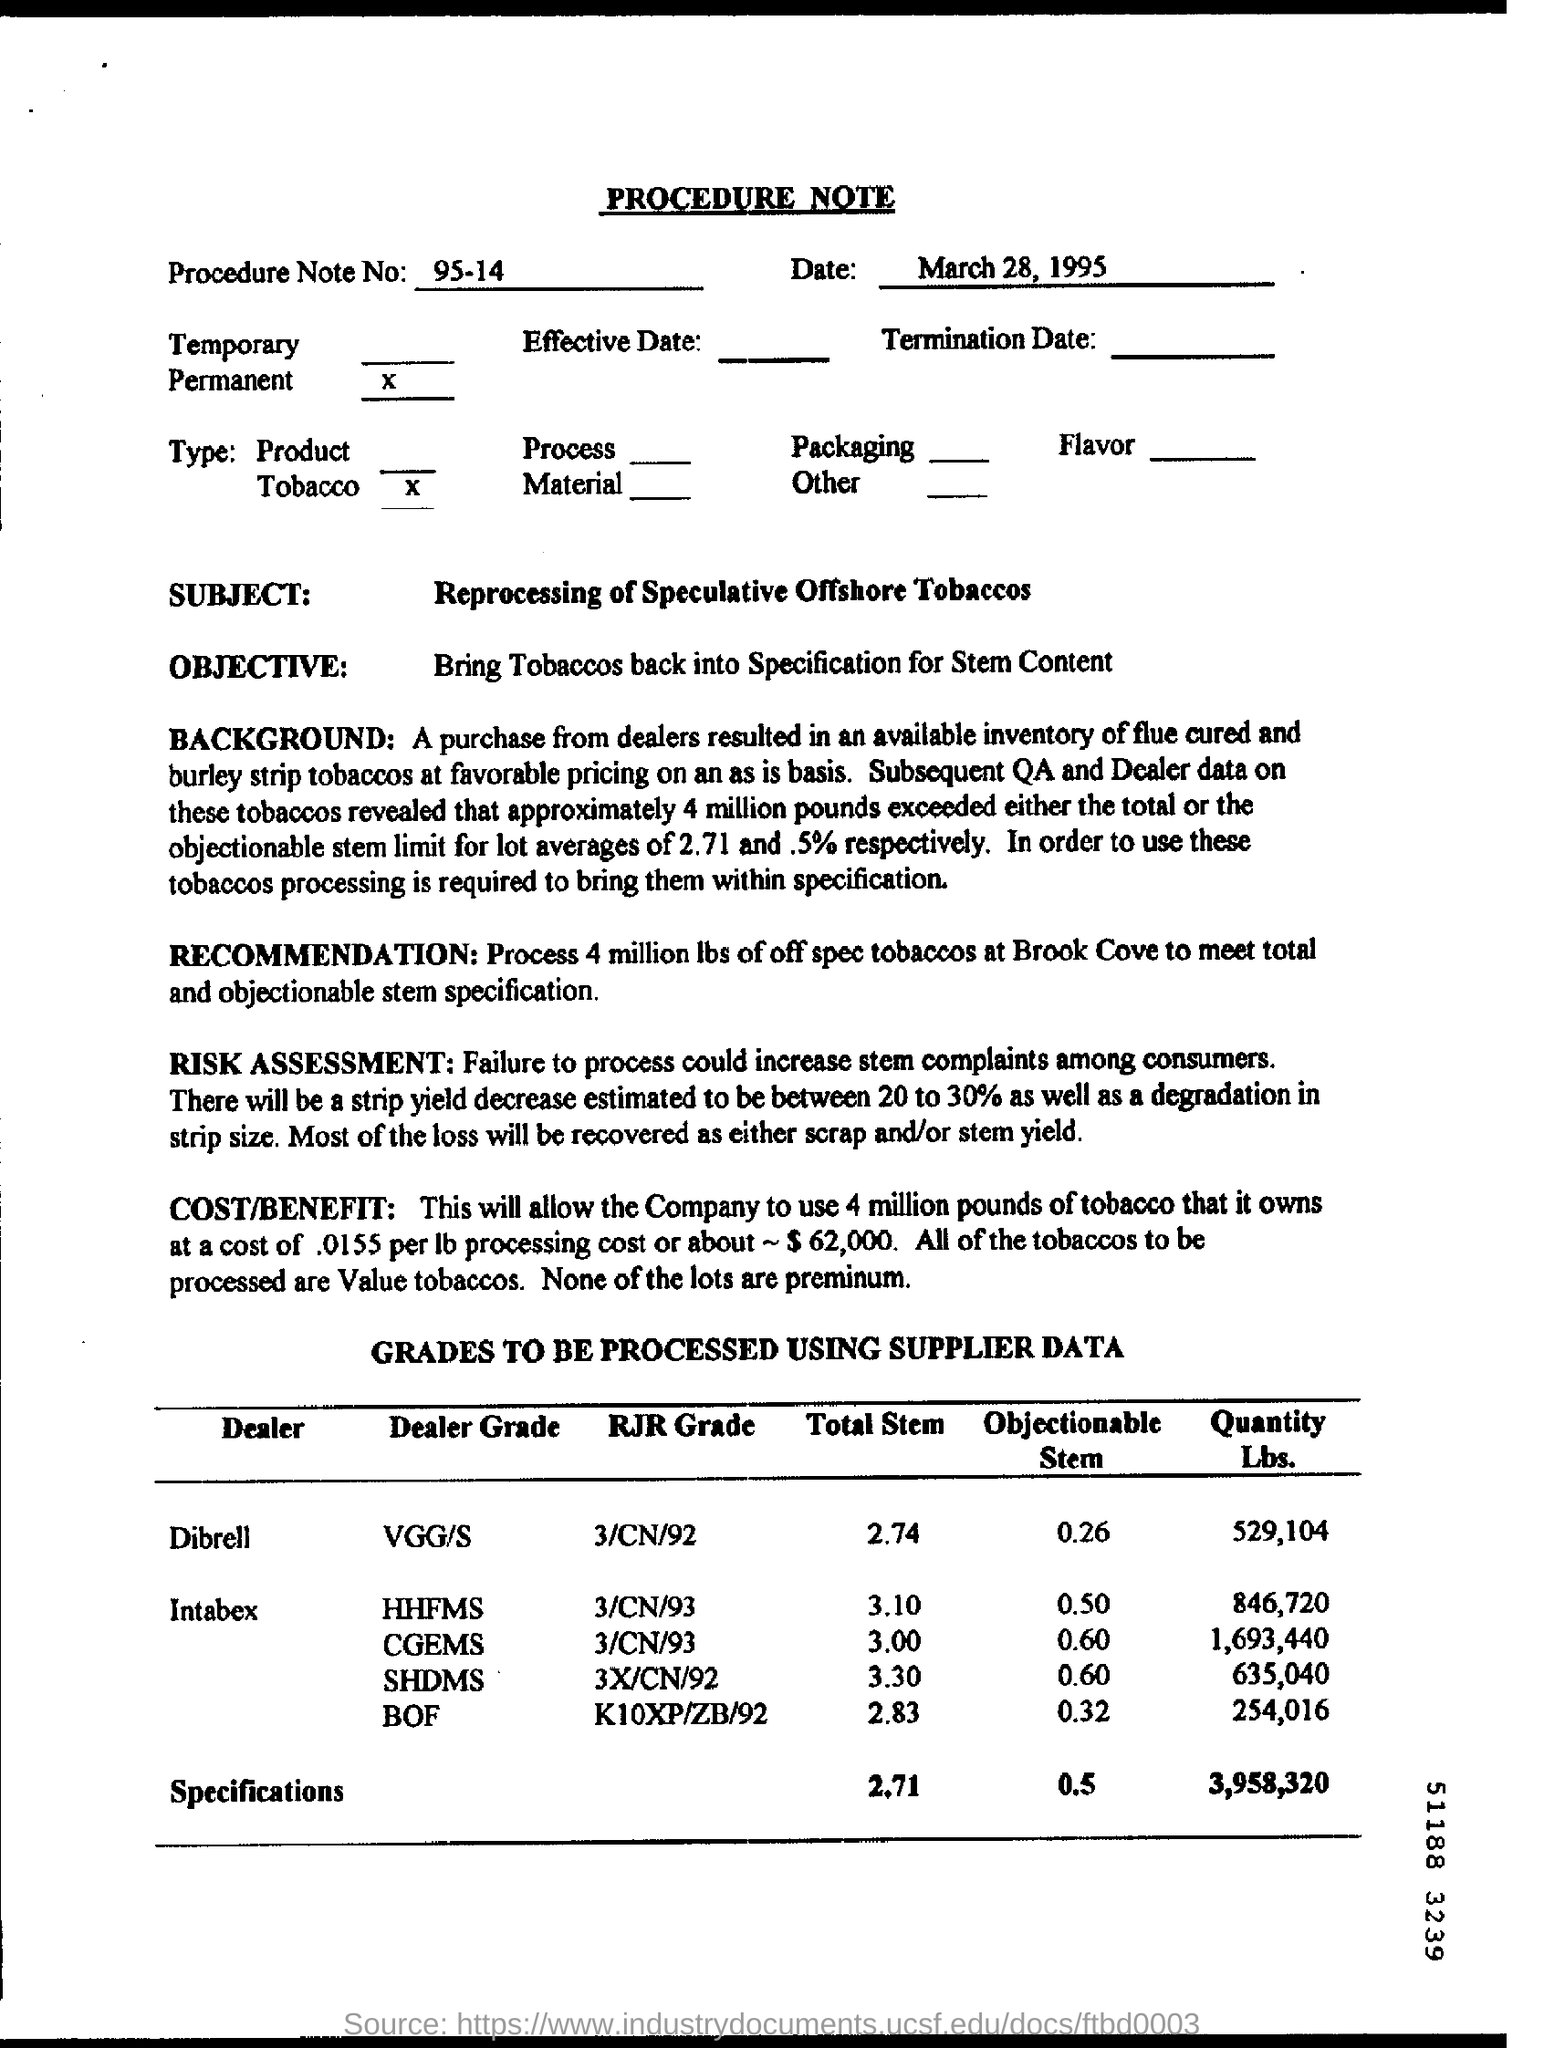Give some essential details in this illustration. The Procedure Note No. is 95-14. What is the Dealer Grade for Dealer "Dibrell"? VGG/S.. The subject of the note is the reprocessing of speculative offshore tobaccos. The date on the procedure note is March 28, 1995. The total stem for dealer "Dibrell" is 2.74. 